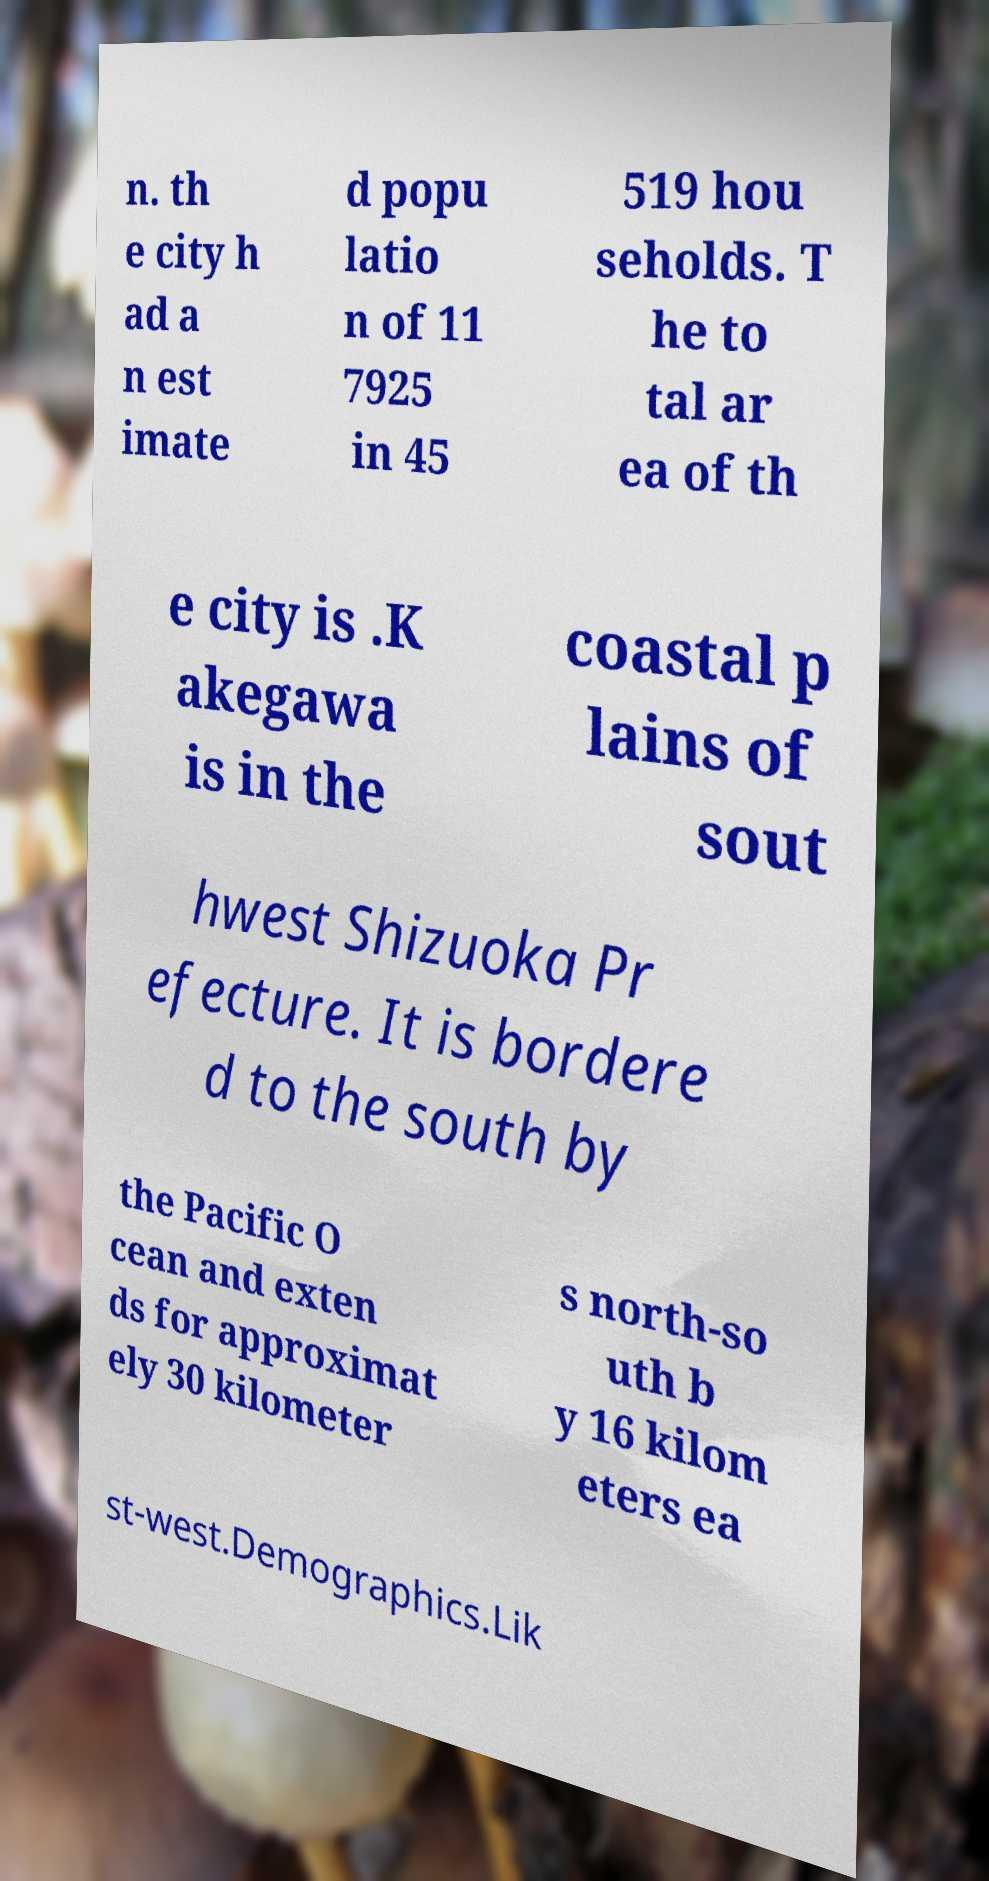For documentation purposes, I need the text within this image transcribed. Could you provide that? n. th e city h ad a n est imate d popu latio n of 11 7925 in 45 519 hou seholds. T he to tal ar ea of th e city is .K akegawa is in the coastal p lains of sout hwest Shizuoka Pr efecture. It is bordere d to the south by the Pacific O cean and exten ds for approximat ely 30 kilometer s north-so uth b y 16 kilom eters ea st-west.Demographics.Lik 